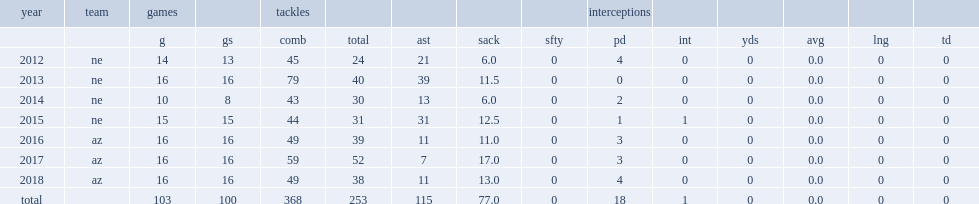How many sacks did jones get in 2015? 12.5. 